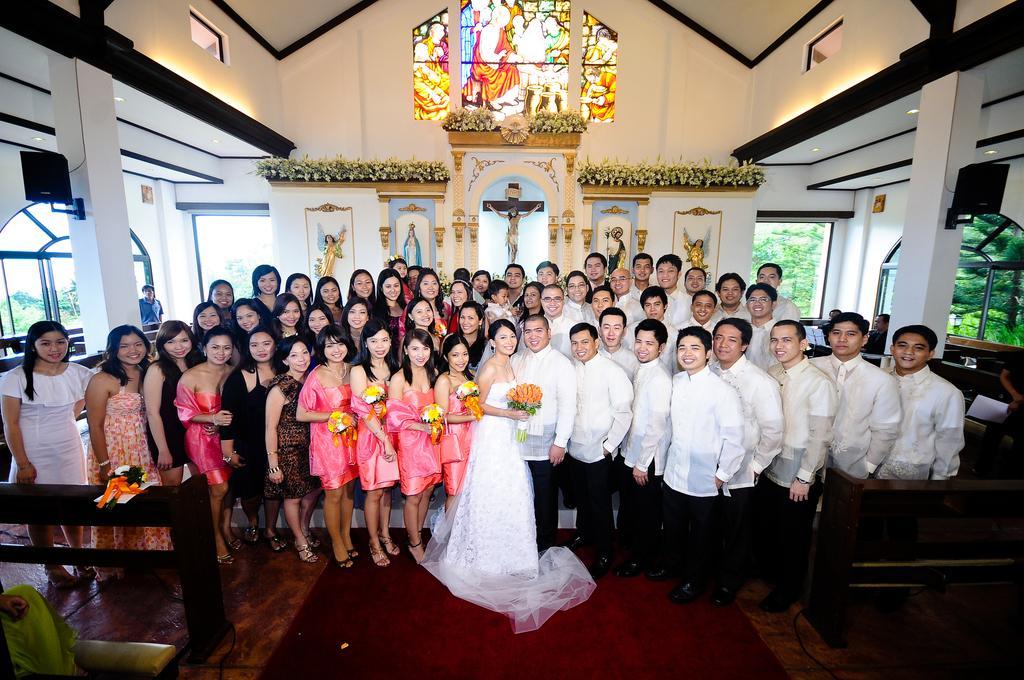Describe this image in one or two sentences. In this image we can see people standing. At the bottom of the image there is wooden floor. In the background of the image there is wall. There are statues. At the top of the image there is ceiling. There are pillars. To the right side of the image there is there is a glass window through which we can see trees. 